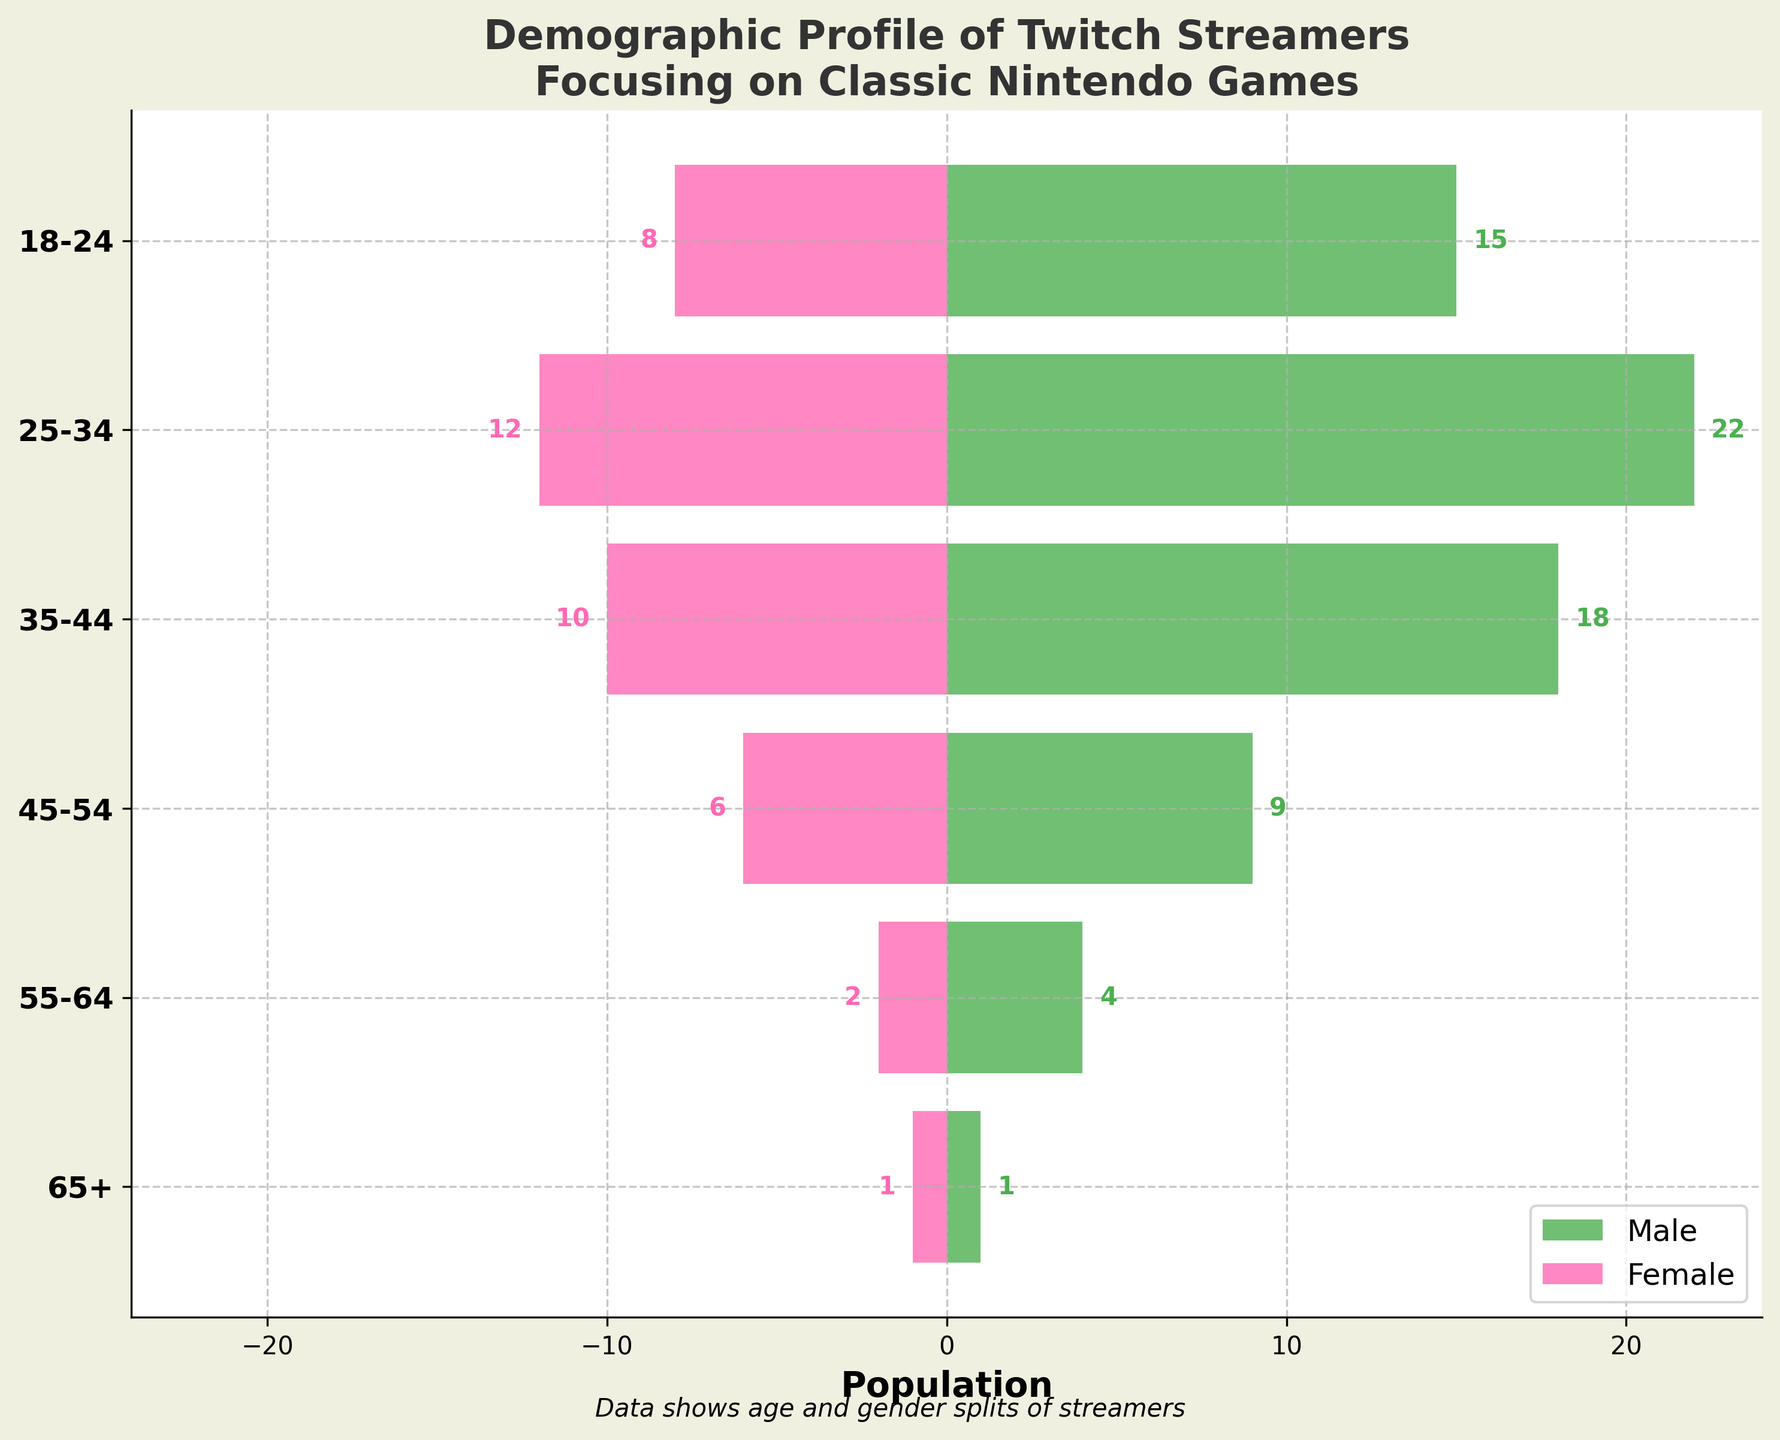What's the title of the figure? The large bold text at the top of the figure provides the title. The title is "Demographic Profile of Twitch Streamers Focusing on Classic Nintendo Games".
Answer: Demographic Profile of Twitch Streamers Focusing on Classic Nintendo Games How many age groups are depicted in the figure? The y-axis lists the age groups. There are 6 distinct age groups labeled as follows: 18-24, 25-34, 35-44, 45-54, 55-64, and 65+.
Answer: 6 Which age group has the highest number of male streamers? By looking at the green bars extending to the right for each age group, the one that extends the farthest is for the 25-34 group, with a value of 22 male streamers.
Answer: 25-34 How many total female streamers are there across all age groups? Adding up the negative values on the left side for female streamers: 8 (18-24) + 12 (25-34) + 10 (35-44) + 6 (45-54) + 2 (55-64) + 1 (65+) = 39.
Answer: 39 What is the difference between the number of male and female streamers in the 35-44 age group? The 35-44 age group has 18 male streamers and 10 female streamers. The difference is calculated as 18 - 10 = 8.
Answer: 8 Which gender is more represented in the 55-64 age group and by how much? In the 55-64 age group, there are 4 male streamers and 2 female streamers. Males are more represented, with a difference of 4 - 2 = 2.
Answer: Males, by 2 What percentage of the total streamers in the 45-54 age group are female? There are 9 male streamers and 6 female streamers in the 45-54 age group. The total is 9 + 6 = 15. The percentage of females is (6/15) * 100 ≈ 40%.
Answer: 40% Is there an age group where the number of male and female streamers is the same? The only age group where the bars for both male and female streamers are the same length is the 65+ age group, both having 1 streamer each.
Answer: 65+ In which age group is the total number of streamers the smallest? By comparing the total sum of male and female streamers in each age group, the 65+ group has the smallest total of 2 streamers (1 male + 1 female).
Answer: 65+ What’s the overall trend in the number of streamers as age increases? Observing the lengths of the bars across the age groups, both male and female streamer populations decrease as age increases, showing a clear trend.
Answer: Decrease 